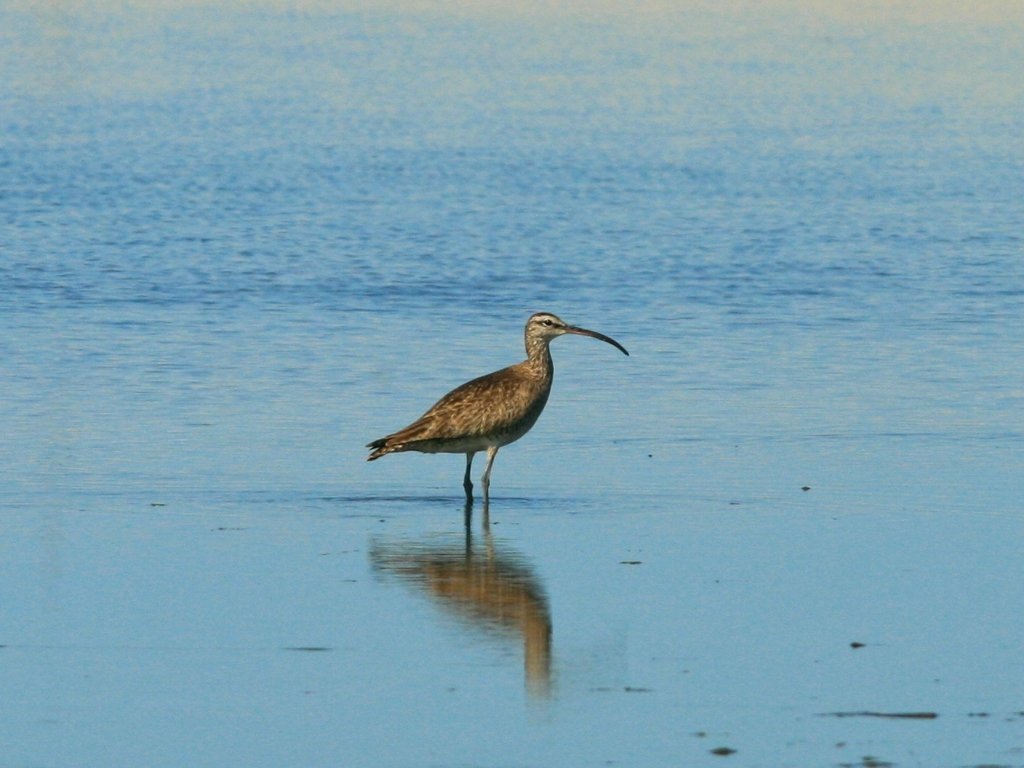What species of bird is this, and can you tell me more about its habitat? Based on the image, the bird resembles a whimbrel, which is known for its long, curved beak and mottled brown plumage. Whimbrels are shorebirds and their habitats include coastal marshes, estuaries, and tidal flats where they feed on invertebrates. 